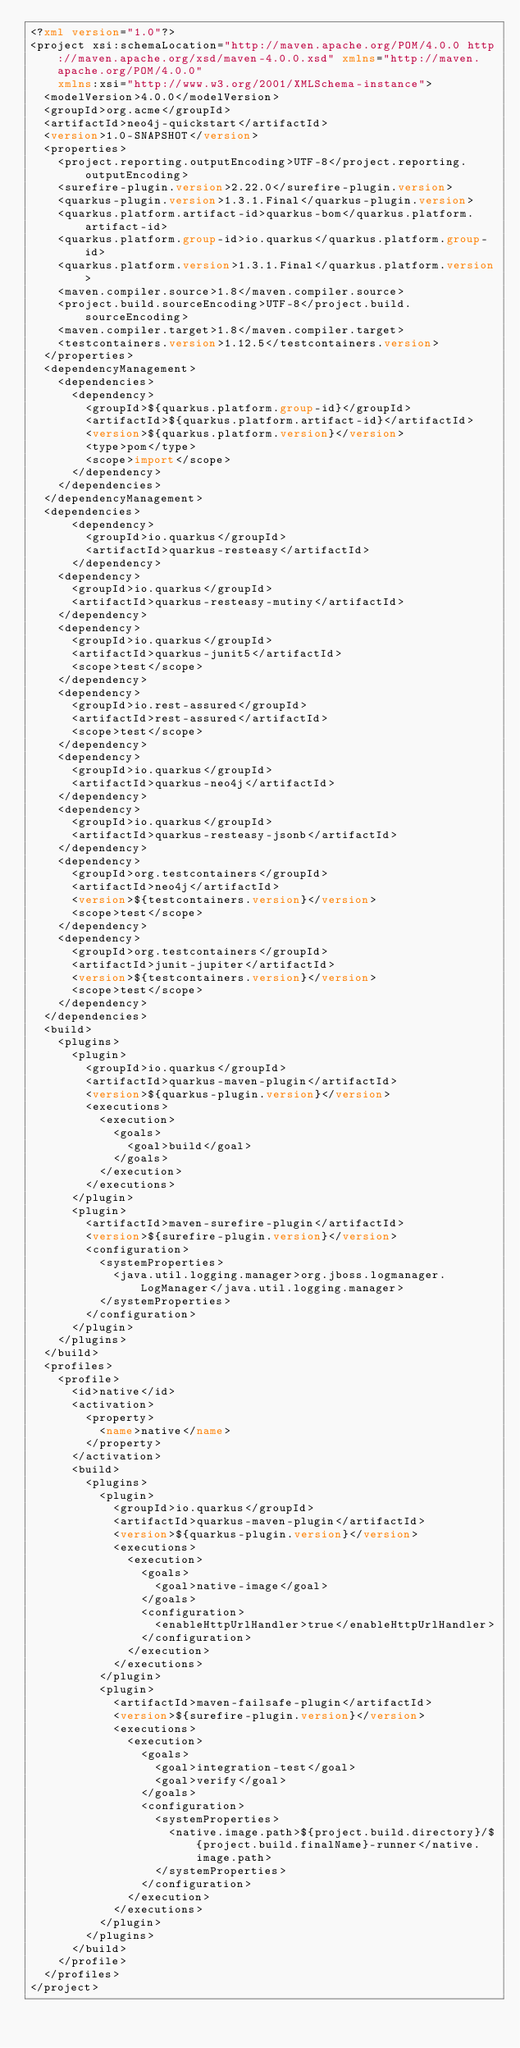Convert code to text. <code><loc_0><loc_0><loc_500><loc_500><_XML_><?xml version="1.0"?>
<project xsi:schemaLocation="http://maven.apache.org/POM/4.0.0 http://maven.apache.org/xsd/maven-4.0.0.xsd" xmlns="http://maven.apache.org/POM/4.0.0"
    xmlns:xsi="http://www.w3.org/2001/XMLSchema-instance">
  <modelVersion>4.0.0</modelVersion>
  <groupId>org.acme</groupId>
  <artifactId>neo4j-quickstart</artifactId>
  <version>1.0-SNAPSHOT</version>
  <properties>
    <project.reporting.outputEncoding>UTF-8</project.reporting.outputEncoding>
    <surefire-plugin.version>2.22.0</surefire-plugin.version>
    <quarkus-plugin.version>1.3.1.Final</quarkus-plugin.version>
    <quarkus.platform.artifact-id>quarkus-bom</quarkus.platform.artifact-id>
    <quarkus.platform.group-id>io.quarkus</quarkus.platform.group-id>
    <quarkus.platform.version>1.3.1.Final</quarkus.platform.version>
    <maven.compiler.source>1.8</maven.compiler.source>
    <project.build.sourceEncoding>UTF-8</project.build.sourceEncoding>
    <maven.compiler.target>1.8</maven.compiler.target>
    <testcontainers.version>1.12.5</testcontainers.version>
  </properties>
  <dependencyManagement>
    <dependencies>
      <dependency>
        <groupId>${quarkus.platform.group-id}</groupId>
        <artifactId>${quarkus.platform.artifact-id}</artifactId>
        <version>${quarkus.platform.version}</version>
        <type>pom</type>
        <scope>import</scope>
      </dependency>
    </dependencies>
  </dependencyManagement>
  <dependencies>
      <dependency>
        <groupId>io.quarkus</groupId>
        <artifactId>quarkus-resteasy</artifactId>
      </dependency>
    <dependency>
      <groupId>io.quarkus</groupId>
      <artifactId>quarkus-resteasy-mutiny</artifactId>
    </dependency>
    <dependency>
      <groupId>io.quarkus</groupId>
      <artifactId>quarkus-junit5</artifactId>
      <scope>test</scope>
    </dependency>
    <dependency>
      <groupId>io.rest-assured</groupId>
      <artifactId>rest-assured</artifactId>
      <scope>test</scope>
    </dependency>
    <dependency>
      <groupId>io.quarkus</groupId>
      <artifactId>quarkus-neo4j</artifactId>
    </dependency>
    <dependency>
      <groupId>io.quarkus</groupId>
      <artifactId>quarkus-resteasy-jsonb</artifactId>
    </dependency>
    <dependency>
      <groupId>org.testcontainers</groupId>
      <artifactId>neo4j</artifactId>
      <version>${testcontainers.version}</version>
      <scope>test</scope>
    </dependency>
    <dependency>
      <groupId>org.testcontainers</groupId>
      <artifactId>junit-jupiter</artifactId>
      <version>${testcontainers.version}</version>
      <scope>test</scope>
    </dependency>
  </dependencies>
  <build>
    <plugins>
      <plugin>
        <groupId>io.quarkus</groupId>
        <artifactId>quarkus-maven-plugin</artifactId>
        <version>${quarkus-plugin.version}</version>
        <executions>
          <execution>
            <goals>
              <goal>build</goal>
            </goals>
          </execution>
        </executions>
      </plugin>
      <plugin>
        <artifactId>maven-surefire-plugin</artifactId>
        <version>${surefire-plugin.version}</version>
        <configuration>
          <systemProperties>
            <java.util.logging.manager>org.jboss.logmanager.LogManager</java.util.logging.manager>
          </systemProperties>
        </configuration>
      </plugin>
    </plugins>
  </build>
  <profiles>
    <profile>
      <id>native</id>
      <activation>
        <property>
          <name>native</name>
        </property>
      </activation>
      <build>
        <plugins>
          <plugin>
            <groupId>io.quarkus</groupId>
            <artifactId>quarkus-maven-plugin</artifactId>
            <version>${quarkus-plugin.version}</version>
            <executions>
              <execution>
                <goals>
                  <goal>native-image</goal>
                </goals>
                <configuration>
                  <enableHttpUrlHandler>true</enableHttpUrlHandler>
                </configuration>
              </execution>
            </executions>
          </plugin>
          <plugin>
            <artifactId>maven-failsafe-plugin</artifactId>
            <version>${surefire-plugin.version}</version>
            <executions>
              <execution>
                <goals>
                  <goal>integration-test</goal>
                  <goal>verify</goal>
                </goals>
                <configuration>
                  <systemProperties>
                    <native.image.path>${project.build.directory}/${project.build.finalName}-runner</native.image.path>
                  </systemProperties>
                </configuration>
              </execution>
            </executions>
          </plugin>
        </plugins>
      </build>
    </profile>
  </profiles>
</project>
</code> 